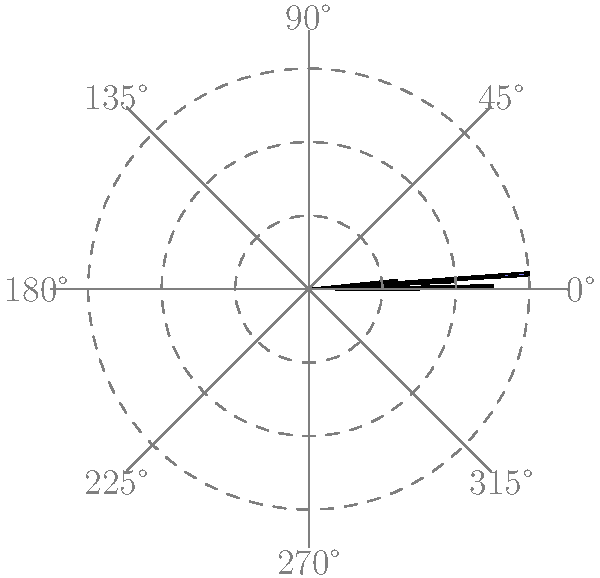Based on the polar histogram showing a team's passing patterns, in which direction did the team make the most passes during the match? To determine the direction with the most passes, we need to analyze the polar histogram:

1. The histogram is divided into 8 sectors, each representing a 45° angle.
2. The length of each sector indicates the number of passes in that direction.
3. Starting from 0° (right) and moving counterclockwise:
   - 0°: Moderate number of passes
   - 45°: High number of passes
   - 90°: Low number of passes
   - 135°: Very low number of passes
   - 180°: Moderate number of passes
   - 225°: Highest number of passes
   - 270°: Low number of passes
   - 315°: Moderate number of passes
4. The longest sector is at 225°, which corresponds to the bottom-left direction.

Therefore, the team made the most passes towards the bottom-left direction (225°) during the match.
Answer: Bottom-left (225°) 